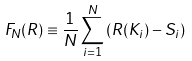Convert formula to latex. <formula><loc_0><loc_0><loc_500><loc_500>F _ { N } ( R ) \equiv \frac { 1 } { N } \sum _ { i = 1 } ^ { N } \left ( R ( K _ { i } ) - S _ { i } \right )</formula> 